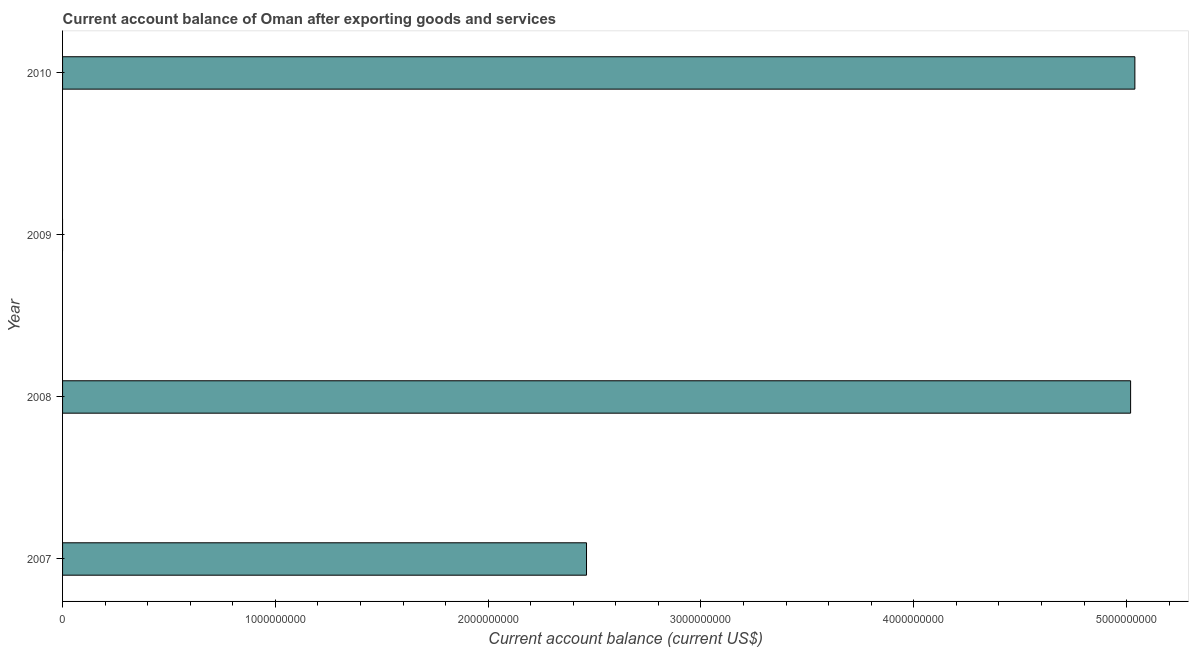Does the graph contain any zero values?
Make the answer very short. Yes. Does the graph contain grids?
Ensure brevity in your answer.  No. What is the title of the graph?
Ensure brevity in your answer.  Current account balance of Oman after exporting goods and services. What is the label or title of the X-axis?
Offer a very short reply. Current account balance (current US$). What is the current account balance in 2010?
Keep it short and to the point. 5.04e+09. Across all years, what is the maximum current account balance?
Give a very brief answer. 5.04e+09. In which year was the current account balance maximum?
Offer a terse response. 2010. What is the sum of the current account balance?
Offer a very short reply. 1.25e+1. What is the difference between the current account balance in 2007 and 2010?
Provide a short and direct response. -2.58e+09. What is the average current account balance per year?
Offer a terse response. 3.13e+09. What is the median current account balance?
Your answer should be very brief. 3.74e+09. In how many years, is the current account balance greater than 3200000000 US$?
Ensure brevity in your answer.  2. Is the current account balance in 2008 less than that in 2010?
Your answer should be very brief. Yes. Is the difference between the current account balance in 2007 and 2010 greater than the difference between any two years?
Provide a succinct answer. No. What is the difference between the highest and the second highest current account balance?
Provide a short and direct response. 2.01e+07. What is the difference between the highest and the lowest current account balance?
Offer a terse response. 5.04e+09. How many bars are there?
Make the answer very short. 3. Are all the bars in the graph horizontal?
Provide a succinct answer. Yes. What is the Current account balance (current US$) in 2007?
Keep it short and to the point. 2.46e+09. What is the Current account balance (current US$) in 2008?
Keep it short and to the point. 5.02e+09. What is the Current account balance (current US$) of 2009?
Provide a short and direct response. 0. What is the Current account balance (current US$) in 2010?
Your response must be concise. 5.04e+09. What is the difference between the Current account balance (current US$) in 2007 and 2008?
Offer a terse response. -2.56e+09. What is the difference between the Current account balance (current US$) in 2007 and 2010?
Offer a terse response. -2.58e+09. What is the difference between the Current account balance (current US$) in 2008 and 2010?
Provide a succinct answer. -2.01e+07. What is the ratio of the Current account balance (current US$) in 2007 to that in 2008?
Offer a very short reply. 0.49. What is the ratio of the Current account balance (current US$) in 2007 to that in 2010?
Make the answer very short. 0.49. What is the ratio of the Current account balance (current US$) in 2008 to that in 2010?
Make the answer very short. 1. 